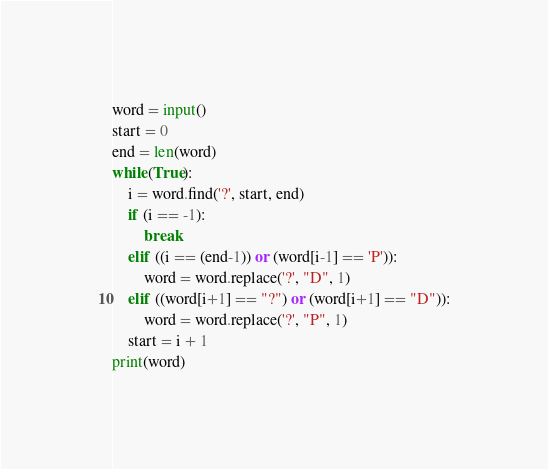Convert code to text. <code><loc_0><loc_0><loc_500><loc_500><_Python_>word = input()
start = 0
end = len(word)
while(True):
	i = word.find('?', start, end)
	if (i == -1):
		break
	elif ((i == (end-1)) or (word[i-1] == 'P')):
		word = word.replace('?', "D", 1)
	elif ((word[i+1] == "?") or (word[i+1] == "D")):
		word = word.replace('?', "P", 1)
	start = i + 1
print(word)</code> 